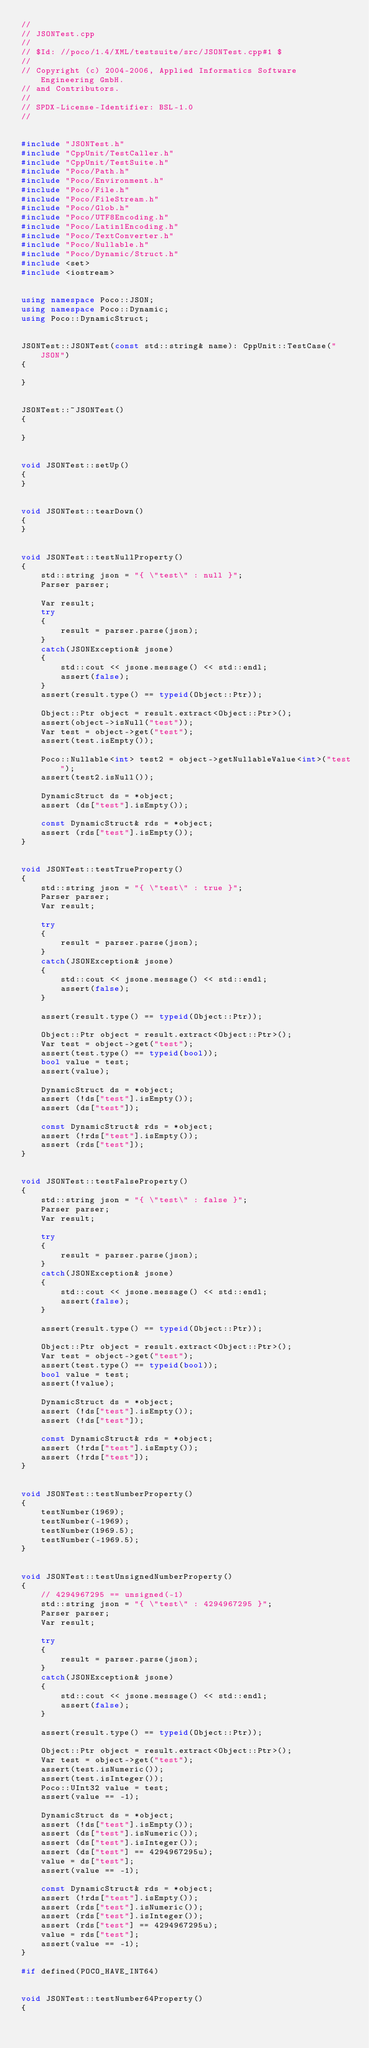<code> <loc_0><loc_0><loc_500><loc_500><_C++_>//
// JSONTest.cpp
//
// $Id: //poco/1.4/XML/testsuite/src/JSONTest.cpp#1 $
//
// Copyright (c) 2004-2006, Applied Informatics Software Engineering GmbH.
// and Contributors.
//
// SPDX-License-Identifier:	BSL-1.0
//


#include "JSONTest.h"
#include "CppUnit/TestCaller.h"
#include "CppUnit/TestSuite.h"
#include "Poco/Path.h"
#include "Poco/Environment.h"
#include "Poco/File.h"
#include "Poco/FileStream.h"
#include "Poco/Glob.h"
#include "Poco/UTF8Encoding.h"
#include "Poco/Latin1Encoding.h"
#include "Poco/TextConverter.h"
#include "Poco/Nullable.h"
#include "Poco/Dynamic/Struct.h"
#include <set>
#include <iostream>


using namespace Poco::JSON;
using namespace Poco::Dynamic;
using Poco::DynamicStruct;


JSONTest::JSONTest(const std::string& name): CppUnit::TestCase("JSON")
{

}


JSONTest::~JSONTest()
{

}


void JSONTest::setUp()
{
}


void JSONTest::tearDown()
{
}


void JSONTest::testNullProperty()
{
	std::string json = "{ \"test\" : null }";
	Parser parser;

	Var result;
	try
	{
		result = parser.parse(json);
	}
	catch(JSONException& jsone)
	{
		std::cout << jsone.message() << std::endl;
		assert(false);
	}
	assert(result.type() == typeid(Object::Ptr));

	Object::Ptr object = result.extract<Object::Ptr>();
	assert(object->isNull("test"));
	Var test = object->get("test");
	assert(test.isEmpty());

	Poco::Nullable<int> test2 = object->getNullableValue<int>("test");
	assert(test2.isNull());

	DynamicStruct ds = *object;
	assert (ds["test"].isEmpty());

	const DynamicStruct& rds = *object;
	assert (rds["test"].isEmpty());
}


void JSONTest::testTrueProperty()
{
	std::string json = "{ \"test\" : true }";
	Parser parser;
	Var result;

	try
	{
		result = parser.parse(json);
	}
	catch(JSONException& jsone)
	{
		std::cout << jsone.message() << std::endl;
		assert(false);
	}

	assert(result.type() == typeid(Object::Ptr));

	Object::Ptr object = result.extract<Object::Ptr>();
	Var test = object->get("test");
	assert(test.type() == typeid(bool));
	bool value = test;
	assert(value);

	DynamicStruct ds = *object;
	assert (!ds["test"].isEmpty());
	assert (ds["test"]);

	const DynamicStruct& rds = *object;
	assert (!rds["test"].isEmpty());
	assert (rds["test"]);
}


void JSONTest::testFalseProperty()
{
	std::string json = "{ \"test\" : false }";
	Parser parser;
	Var result;

	try
	{
		result = parser.parse(json);
	}
	catch(JSONException& jsone)
	{
		std::cout << jsone.message() << std::endl;
		assert(false);
	}

	assert(result.type() == typeid(Object::Ptr));

	Object::Ptr object = result.extract<Object::Ptr>();
	Var test = object->get("test");
	assert(test.type() == typeid(bool));
	bool value = test;
	assert(!value);

	DynamicStruct ds = *object;
	assert (!ds["test"].isEmpty());
	assert (!ds["test"]);

	const DynamicStruct& rds = *object;
	assert (!rds["test"].isEmpty());
	assert (!rds["test"]);
}


void JSONTest::testNumberProperty()
{
	testNumber(1969);
	testNumber(-1969);
	testNumber(1969.5);
	testNumber(-1969.5);
}


void JSONTest::testUnsignedNumberProperty()
{
	// 4294967295 == unsigned(-1)
	std::string json = "{ \"test\" : 4294967295 }";
	Parser parser;
	Var result;

	try
	{
		result = parser.parse(json);
	}
	catch(JSONException& jsone)
	{
		std::cout << jsone.message() << std::endl;
		assert(false);
	}

	assert(result.type() == typeid(Object::Ptr));

	Object::Ptr object = result.extract<Object::Ptr>();
	Var test = object->get("test");
	assert(test.isNumeric());
	assert(test.isInteger());
	Poco::UInt32 value = test;
	assert(value == -1);

	DynamicStruct ds = *object;
	assert (!ds["test"].isEmpty());
	assert (ds["test"].isNumeric());
	assert (ds["test"].isInteger());
	assert (ds["test"] == 4294967295u);
	value = ds["test"];
	assert(value == -1);

	const DynamicStruct& rds = *object;
	assert (!rds["test"].isEmpty());
	assert (rds["test"].isNumeric());
	assert (rds["test"].isInteger());
	assert (rds["test"] == 4294967295u);
	value = rds["test"];
	assert(value == -1);
}

#if defined(POCO_HAVE_INT64)


void JSONTest::testNumber64Property()
{</code> 